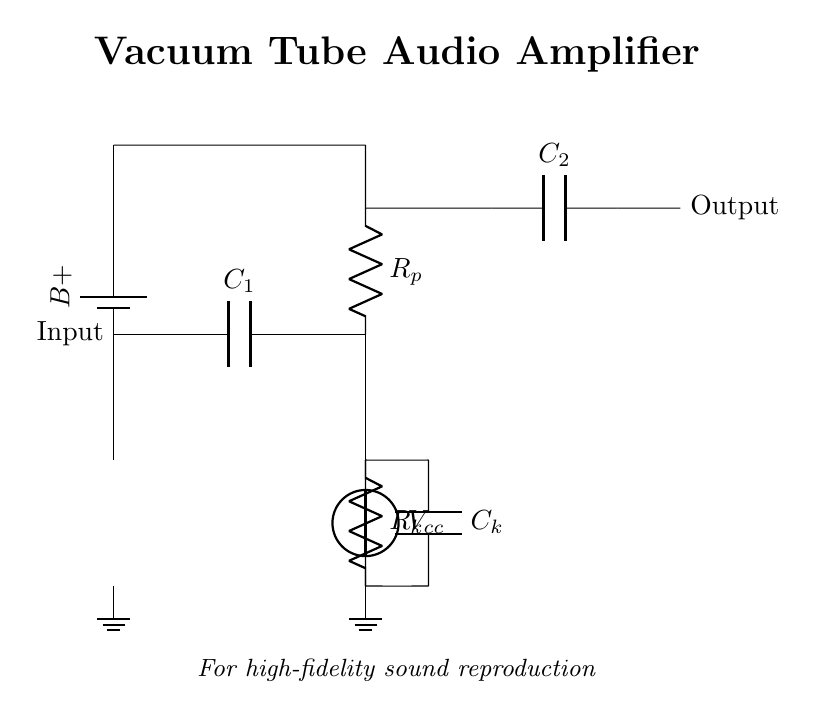What type of component is Vcc? Vcc is a voltage source that supplies power to the circuit. It provides the necessary energy for the vacuum tube to operate.
Answer: Voltage source What is the function of C1? C1 is a coupling capacitor that allows AC signals to pass while blocking DC. This prevents any DC voltage from affecting subsequent stages of the circuit.
Answer: Coupling What is the value of Rk? Rk is the cathode resistor; its specific value isn't shown in the diagram, but it is crucial for setting the operating point of the tube by providing necessary biasing.
Answer: Not specified What is located at the output? The output has an output coupling capacitor that allows the amplified audio signal to pass to the load, ensuring that only AC passes to the next stage or speaker.
Answer: Output coupling capacitor How many vacuum tubes are used in this circuit? There is one vacuum tube depicted in the circuit, which is essential for amplification in this design.
Answer: One What role does C2 play in this circuit? C2 acts as an output coupling capacitor, similarly to C1, allowing the audio signal to pass to the output while preventing any DC offset from reaching the speakers or next stages.
Answer: Output coupling capacitor What is the purpose of the battery in this circuit? The battery provides the necessary high voltage (Vcc) required for the vacuum tube operation, essential for generating the amplified audio output.
Answer: Power supply 